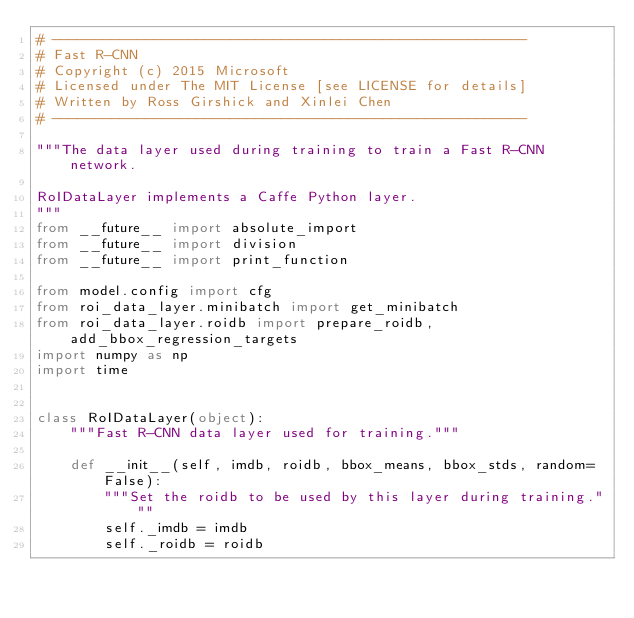<code> <loc_0><loc_0><loc_500><loc_500><_Python_># --------------------------------------------------------
# Fast R-CNN
# Copyright (c) 2015 Microsoft
# Licensed under The MIT License [see LICENSE for details]
# Written by Ross Girshick and Xinlei Chen
# --------------------------------------------------------

"""The data layer used during training to train a Fast R-CNN network.

RoIDataLayer implements a Caffe Python layer.
"""
from __future__ import absolute_import
from __future__ import division
from __future__ import print_function

from model.config import cfg
from roi_data_layer.minibatch import get_minibatch
from roi_data_layer.roidb import prepare_roidb, add_bbox_regression_targets
import numpy as np
import time


class RoIDataLayer(object):
    """Fast R-CNN data layer used for training."""

    def __init__(self, imdb, roidb, bbox_means, bbox_stds, random=False):
        """Set the roidb to be used by this layer during training."""
        self._imdb = imdb
        self._roidb = roidb</code> 